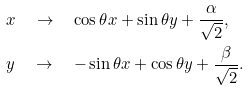Convert formula to latex. <formula><loc_0><loc_0><loc_500><loc_500>& x \quad \to \quad \cos \theta x + \sin \theta y + \frac { \alpha } { \sqrt { 2 } } , \\ & y \quad \to \quad - \sin \theta x + \cos \theta y + \frac { \beta } { \sqrt { 2 } } .</formula> 